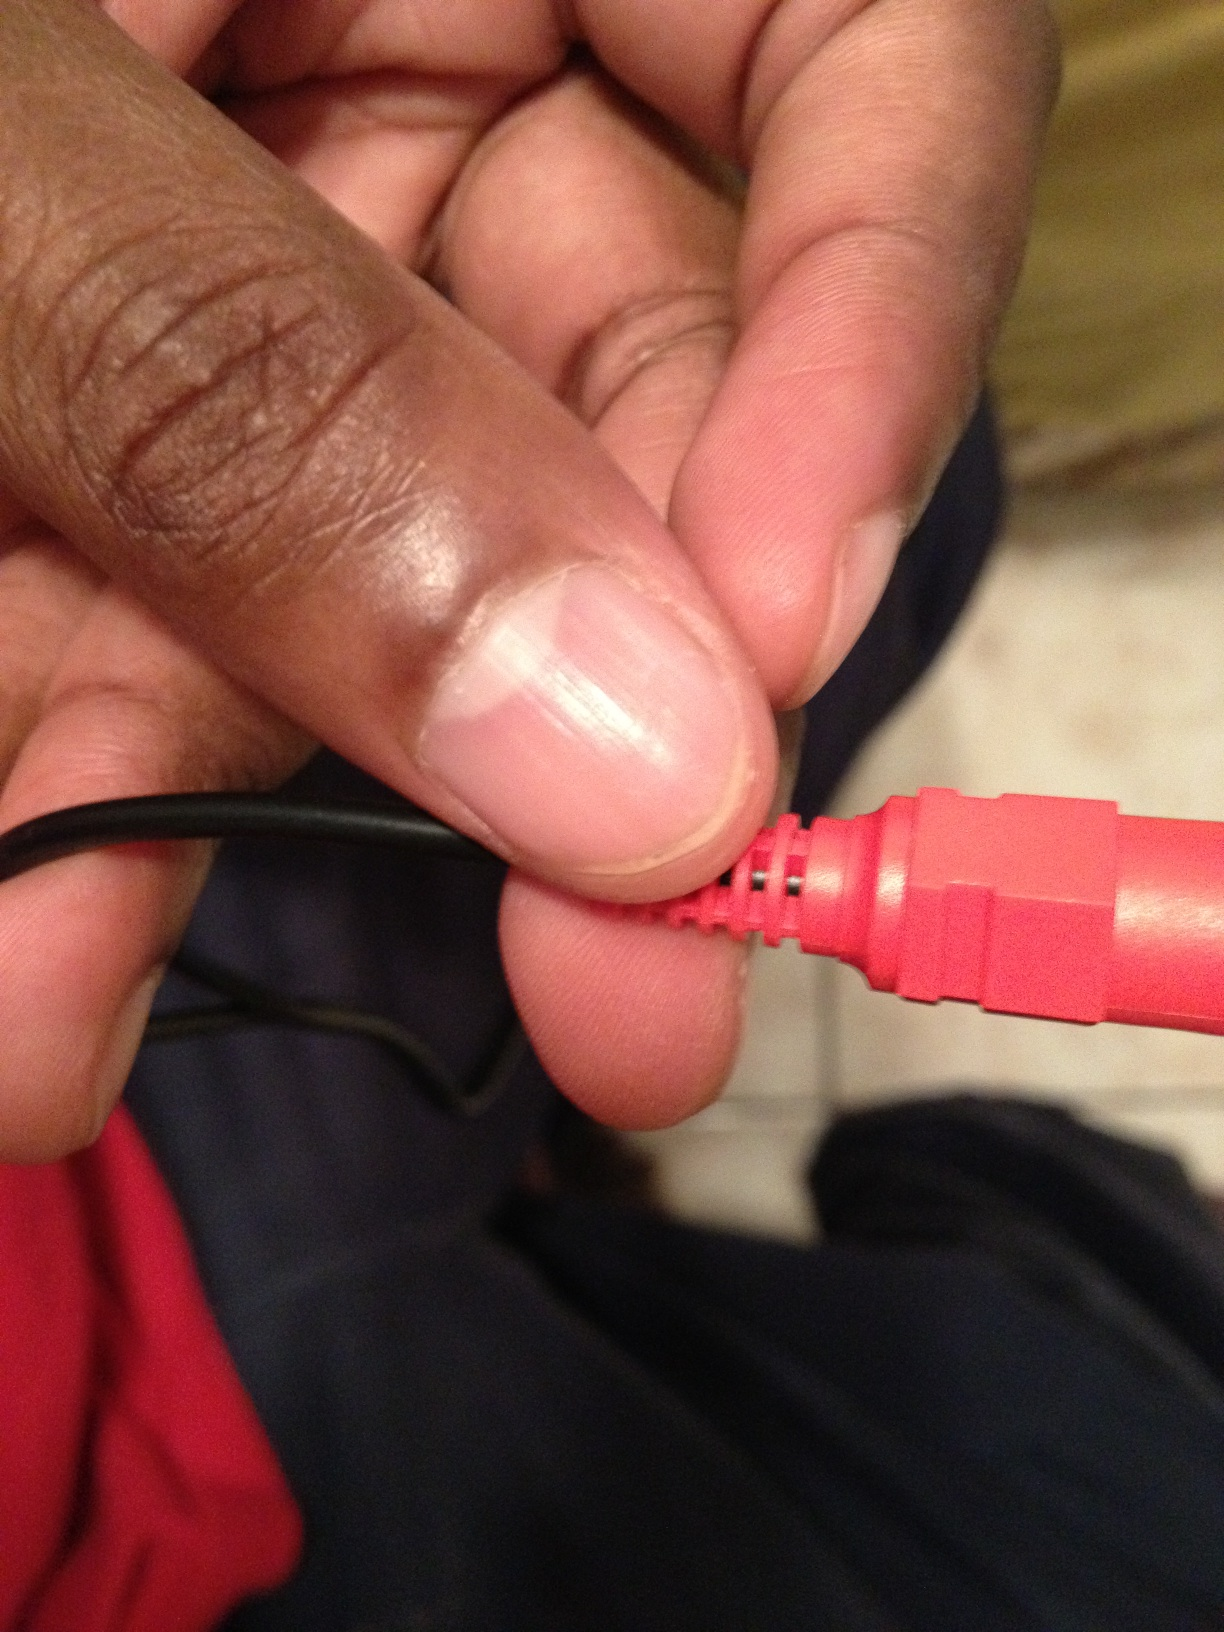Why are connectors like these typically used in red color? Connectors are often color-coded for easy identification and to ensure proper connections are made during installation. Red is commonly used for right audio channels in stereo setups or for power connections in some electronic configurations. Can you describe a scenario where this type of connector might be used? Certainly! Imagine setting up a home theater system. You might have several cables to connect to your receiver, speakers, and television. The red connector would be used for the right audio channel, ensuring that audio signals are correctly routed for an immersive surround sound experience. 